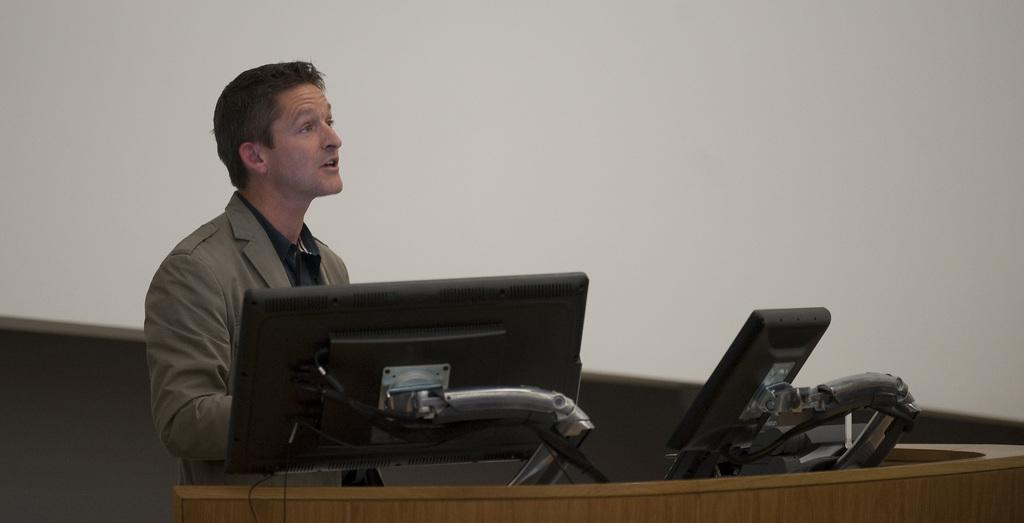What is the main subject of the image? There is a person standing in the image. What electronic device can be seen in the image? There is a computer in the image. What other device is present in the image? There is a device in the image. What type of material is used for the wooden object? The wooden object in the image is made of wood. What color is the background of the image? The background of the image is white. Can you see a receipt on the table in the image? There is no table present in the image, and therefore no receipt can be seen on it. 